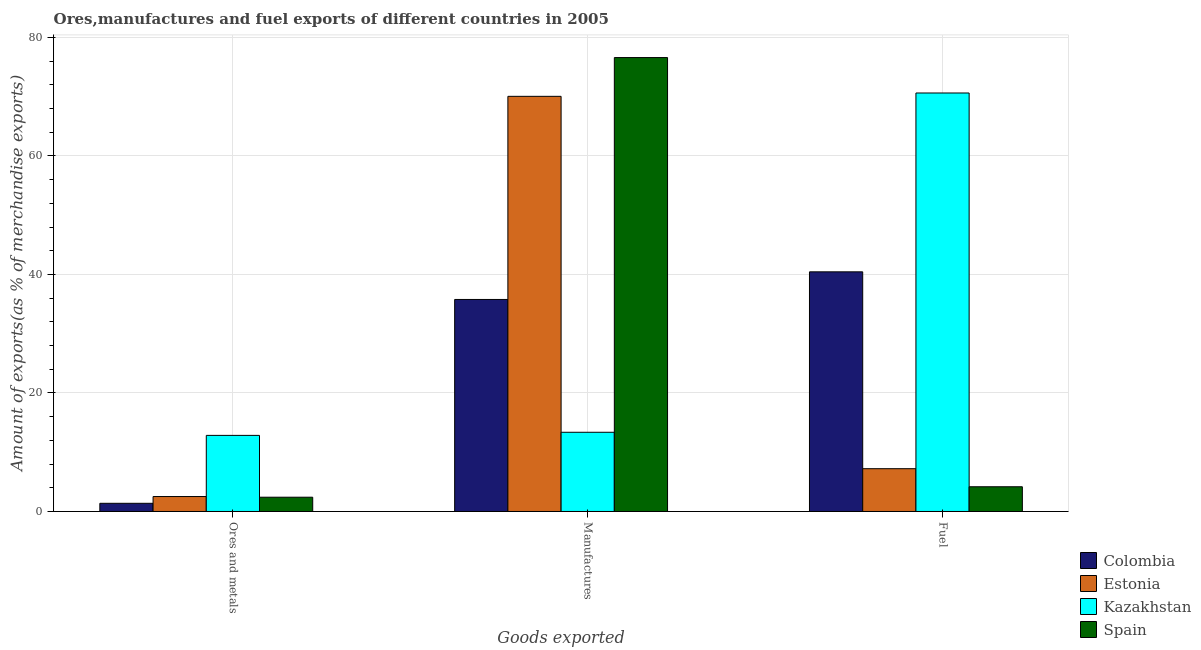How many groups of bars are there?
Ensure brevity in your answer.  3. Are the number of bars per tick equal to the number of legend labels?
Your answer should be very brief. Yes. Are the number of bars on each tick of the X-axis equal?
Provide a succinct answer. Yes. How many bars are there on the 2nd tick from the left?
Offer a very short reply. 4. How many bars are there on the 3rd tick from the right?
Give a very brief answer. 4. What is the label of the 1st group of bars from the left?
Give a very brief answer. Ores and metals. What is the percentage of manufactures exports in Spain?
Provide a short and direct response. 76.6. Across all countries, what is the maximum percentage of manufactures exports?
Your answer should be very brief. 76.6. Across all countries, what is the minimum percentage of fuel exports?
Provide a short and direct response. 4.17. In which country was the percentage of fuel exports maximum?
Offer a terse response. Kazakhstan. In which country was the percentage of manufactures exports minimum?
Make the answer very short. Kazakhstan. What is the total percentage of manufactures exports in the graph?
Give a very brief answer. 195.8. What is the difference between the percentage of manufactures exports in Colombia and that in Spain?
Make the answer very short. -40.82. What is the difference between the percentage of manufactures exports in Spain and the percentage of fuel exports in Estonia?
Offer a very short reply. 69.38. What is the average percentage of manufactures exports per country?
Ensure brevity in your answer.  48.95. What is the difference between the percentage of manufactures exports and percentage of fuel exports in Colombia?
Offer a terse response. -4.66. In how many countries, is the percentage of manufactures exports greater than 72 %?
Provide a succinct answer. 1. What is the ratio of the percentage of ores and metals exports in Estonia to that in Colombia?
Provide a short and direct response. 1.83. Is the percentage of manufactures exports in Spain less than that in Colombia?
Make the answer very short. No. Is the difference between the percentage of fuel exports in Spain and Colombia greater than the difference between the percentage of ores and metals exports in Spain and Colombia?
Offer a very short reply. No. What is the difference between the highest and the second highest percentage of manufactures exports?
Your answer should be very brief. 6.54. What is the difference between the highest and the lowest percentage of manufactures exports?
Provide a succinct answer. 63.23. In how many countries, is the percentage of fuel exports greater than the average percentage of fuel exports taken over all countries?
Ensure brevity in your answer.  2. Is the sum of the percentage of ores and metals exports in Kazakhstan and Estonia greater than the maximum percentage of fuel exports across all countries?
Keep it short and to the point. No. What does the 4th bar from the right in Fuel represents?
Provide a short and direct response. Colombia. Is it the case that in every country, the sum of the percentage of ores and metals exports and percentage of manufactures exports is greater than the percentage of fuel exports?
Give a very brief answer. No. How many bars are there?
Your response must be concise. 12. Where does the legend appear in the graph?
Your answer should be compact. Bottom right. What is the title of the graph?
Your answer should be compact. Ores,manufactures and fuel exports of different countries in 2005. What is the label or title of the X-axis?
Give a very brief answer. Goods exported. What is the label or title of the Y-axis?
Make the answer very short. Amount of exports(as % of merchandise exports). What is the Amount of exports(as % of merchandise exports) of Colombia in Ores and metals?
Make the answer very short. 1.38. What is the Amount of exports(as % of merchandise exports) of Estonia in Ores and metals?
Provide a succinct answer. 2.52. What is the Amount of exports(as % of merchandise exports) of Kazakhstan in Ores and metals?
Provide a succinct answer. 12.84. What is the Amount of exports(as % of merchandise exports) in Spain in Ores and metals?
Your answer should be very brief. 2.41. What is the Amount of exports(as % of merchandise exports) in Colombia in Manufactures?
Provide a short and direct response. 35.78. What is the Amount of exports(as % of merchandise exports) of Estonia in Manufactures?
Your answer should be very brief. 70.05. What is the Amount of exports(as % of merchandise exports) of Kazakhstan in Manufactures?
Provide a short and direct response. 13.37. What is the Amount of exports(as % of merchandise exports) in Spain in Manufactures?
Offer a very short reply. 76.6. What is the Amount of exports(as % of merchandise exports) in Colombia in Fuel?
Give a very brief answer. 40.44. What is the Amount of exports(as % of merchandise exports) of Estonia in Fuel?
Give a very brief answer. 7.22. What is the Amount of exports(as % of merchandise exports) of Kazakhstan in Fuel?
Your response must be concise. 70.62. What is the Amount of exports(as % of merchandise exports) in Spain in Fuel?
Make the answer very short. 4.17. Across all Goods exported, what is the maximum Amount of exports(as % of merchandise exports) of Colombia?
Provide a succinct answer. 40.44. Across all Goods exported, what is the maximum Amount of exports(as % of merchandise exports) of Estonia?
Offer a terse response. 70.05. Across all Goods exported, what is the maximum Amount of exports(as % of merchandise exports) in Kazakhstan?
Offer a very short reply. 70.62. Across all Goods exported, what is the maximum Amount of exports(as % of merchandise exports) in Spain?
Your answer should be very brief. 76.6. Across all Goods exported, what is the minimum Amount of exports(as % of merchandise exports) in Colombia?
Keep it short and to the point. 1.38. Across all Goods exported, what is the minimum Amount of exports(as % of merchandise exports) of Estonia?
Offer a very short reply. 2.52. Across all Goods exported, what is the minimum Amount of exports(as % of merchandise exports) of Kazakhstan?
Give a very brief answer. 12.84. Across all Goods exported, what is the minimum Amount of exports(as % of merchandise exports) in Spain?
Your response must be concise. 2.41. What is the total Amount of exports(as % of merchandise exports) of Colombia in the graph?
Ensure brevity in your answer.  77.6. What is the total Amount of exports(as % of merchandise exports) in Estonia in the graph?
Your answer should be compact. 79.79. What is the total Amount of exports(as % of merchandise exports) of Kazakhstan in the graph?
Your answer should be very brief. 96.83. What is the total Amount of exports(as % of merchandise exports) of Spain in the graph?
Your response must be concise. 83.18. What is the difference between the Amount of exports(as % of merchandise exports) of Colombia in Ores and metals and that in Manufactures?
Give a very brief answer. -34.4. What is the difference between the Amount of exports(as % of merchandise exports) in Estonia in Ores and metals and that in Manufactures?
Provide a succinct answer. -67.53. What is the difference between the Amount of exports(as % of merchandise exports) of Kazakhstan in Ores and metals and that in Manufactures?
Provide a short and direct response. -0.53. What is the difference between the Amount of exports(as % of merchandise exports) of Spain in Ores and metals and that in Manufactures?
Ensure brevity in your answer.  -74.19. What is the difference between the Amount of exports(as % of merchandise exports) of Colombia in Ores and metals and that in Fuel?
Your answer should be compact. -39.06. What is the difference between the Amount of exports(as % of merchandise exports) in Estonia in Ores and metals and that in Fuel?
Provide a short and direct response. -4.7. What is the difference between the Amount of exports(as % of merchandise exports) of Kazakhstan in Ores and metals and that in Fuel?
Your answer should be very brief. -57.78. What is the difference between the Amount of exports(as % of merchandise exports) in Spain in Ores and metals and that in Fuel?
Your response must be concise. -1.77. What is the difference between the Amount of exports(as % of merchandise exports) in Colombia in Manufactures and that in Fuel?
Keep it short and to the point. -4.66. What is the difference between the Amount of exports(as % of merchandise exports) of Estonia in Manufactures and that in Fuel?
Your answer should be very brief. 62.84. What is the difference between the Amount of exports(as % of merchandise exports) of Kazakhstan in Manufactures and that in Fuel?
Provide a short and direct response. -57.25. What is the difference between the Amount of exports(as % of merchandise exports) in Spain in Manufactures and that in Fuel?
Your answer should be very brief. 72.42. What is the difference between the Amount of exports(as % of merchandise exports) in Colombia in Ores and metals and the Amount of exports(as % of merchandise exports) in Estonia in Manufactures?
Keep it short and to the point. -68.67. What is the difference between the Amount of exports(as % of merchandise exports) in Colombia in Ores and metals and the Amount of exports(as % of merchandise exports) in Kazakhstan in Manufactures?
Your answer should be very brief. -11.99. What is the difference between the Amount of exports(as % of merchandise exports) in Colombia in Ores and metals and the Amount of exports(as % of merchandise exports) in Spain in Manufactures?
Give a very brief answer. -75.21. What is the difference between the Amount of exports(as % of merchandise exports) in Estonia in Ores and metals and the Amount of exports(as % of merchandise exports) in Kazakhstan in Manufactures?
Offer a terse response. -10.85. What is the difference between the Amount of exports(as % of merchandise exports) in Estonia in Ores and metals and the Amount of exports(as % of merchandise exports) in Spain in Manufactures?
Make the answer very short. -74.07. What is the difference between the Amount of exports(as % of merchandise exports) of Kazakhstan in Ores and metals and the Amount of exports(as % of merchandise exports) of Spain in Manufactures?
Offer a very short reply. -63.75. What is the difference between the Amount of exports(as % of merchandise exports) of Colombia in Ores and metals and the Amount of exports(as % of merchandise exports) of Estonia in Fuel?
Your response must be concise. -5.84. What is the difference between the Amount of exports(as % of merchandise exports) in Colombia in Ores and metals and the Amount of exports(as % of merchandise exports) in Kazakhstan in Fuel?
Make the answer very short. -69.24. What is the difference between the Amount of exports(as % of merchandise exports) in Colombia in Ores and metals and the Amount of exports(as % of merchandise exports) in Spain in Fuel?
Your answer should be very brief. -2.79. What is the difference between the Amount of exports(as % of merchandise exports) in Estonia in Ores and metals and the Amount of exports(as % of merchandise exports) in Kazakhstan in Fuel?
Make the answer very short. -68.1. What is the difference between the Amount of exports(as % of merchandise exports) in Estonia in Ores and metals and the Amount of exports(as % of merchandise exports) in Spain in Fuel?
Give a very brief answer. -1.65. What is the difference between the Amount of exports(as % of merchandise exports) of Kazakhstan in Ores and metals and the Amount of exports(as % of merchandise exports) of Spain in Fuel?
Keep it short and to the point. 8.67. What is the difference between the Amount of exports(as % of merchandise exports) in Colombia in Manufactures and the Amount of exports(as % of merchandise exports) in Estonia in Fuel?
Offer a terse response. 28.56. What is the difference between the Amount of exports(as % of merchandise exports) of Colombia in Manufactures and the Amount of exports(as % of merchandise exports) of Kazakhstan in Fuel?
Ensure brevity in your answer.  -34.84. What is the difference between the Amount of exports(as % of merchandise exports) of Colombia in Manufactures and the Amount of exports(as % of merchandise exports) of Spain in Fuel?
Your answer should be very brief. 31.61. What is the difference between the Amount of exports(as % of merchandise exports) in Estonia in Manufactures and the Amount of exports(as % of merchandise exports) in Kazakhstan in Fuel?
Your response must be concise. -0.56. What is the difference between the Amount of exports(as % of merchandise exports) in Estonia in Manufactures and the Amount of exports(as % of merchandise exports) in Spain in Fuel?
Offer a terse response. 65.88. What is the difference between the Amount of exports(as % of merchandise exports) in Kazakhstan in Manufactures and the Amount of exports(as % of merchandise exports) in Spain in Fuel?
Keep it short and to the point. 9.19. What is the average Amount of exports(as % of merchandise exports) in Colombia per Goods exported?
Offer a terse response. 25.87. What is the average Amount of exports(as % of merchandise exports) of Estonia per Goods exported?
Offer a very short reply. 26.6. What is the average Amount of exports(as % of merchandise exports) of Kazakhstan per Goods exported?
Ensure brevity in your answer.  32.28. What is the average Amount of exports(as % of merchandise exports) of Spain per Goods exported?
Your answer should be very brief. 27.73. What is the difference between the Amount of exports(as % of merchandise exports) of Colombia and Amount of exports(as % of merchandise exports) of Estonia in Ores and metals?
Provide a succinct answer. -1.14. What is the difference between the Amount of exports(as % of merchandise exports) in Colombia and Amount of exports(as % of merchandise exports) in Kazakhstan in Ores and metals?
Keep it short and to the point. -11.46. What is the difference between the Amount of exports(as % of merchandise exports) in Colombia and Amount of exports(as % of merchandise exports) in Spain in Ores and metals?
Your response must be concise. -1.03. What is the difference between the Amount of exports(as % of merchandise exports) of Estonia and Amount of exports(as % of merchandise exports) of Kazakhstan in Ores and metals?
Your answer should be compact. -10.32. What is the difference between the Amount of exports(as % of merchandise exports) of Estonia and Amount of exports(as % of merchandise exports) of Spain in Ores and metals?
Your answer should be compact. 0.11. What is the difference between the Amount of exports(as % of merchandise exports) of Kazakhstan and Amount of exports(as % of merchandise exports) of Spain in Ores and metals?
Your answer should be compact. 10.43. What is the difference between the Amount of exports(as % of merchandise exports) of Colombia and Amount of exports(as % of merchandise exports) of Estonia in Manufactures?
Provide a succinct answer. -34.28. What is the difference between the Amount of exports(as % of merchandise exports) in Colombia and Amount of exports(as % of merchandise exports) in Kazakhstan in Manufactures?
Give a very brief answer. 22.41. What is the difference between the Amount of exports(as % of merchandise exports) of Colombia and Amount of exports(as % of merchandise exports) of Spain in Manufactures?
Your response must be concise. -40.82. What is the difference between the Amount of exports(as % of merchandise exports) in Estonia and Amount of exports(as % of merchandise exports) in Kazakhstan in Manufactures?
Offer a very short reply. 56.69. What is the difference between the Amount of exports(as % of merchandise exports) in Estonia and Amount of exports(as % of merchandise exports) in Spain in Manufactures?
Your answer should be very brief. -6.54. What is the difference between the Amount of exports(as % of merchandise exports) of Kazakhstan and Amount of exports(as % of merchandise exports) of Spain in Manufactures?
Your response must be concise. -63.23. What is the difference between the Amount of exports(as % of merchandise exports) in Colombia and Amount of exports(as % of merchandise exports) in Estonia in Fuel?
Your answer should be very brief. 33.22. What is the difference between the Amount of exports(as % of merchandise exports) in Colombia and Amount of exports(as % of merchandise exports) in Kazakhstan in Fuel?
Keep it short and to the point. -30.18. What is the difference between the Amount of exports(as % of merchandise exports) in Colombia and Amount of exports(as % of merchandise exports) in Spain in Fuel?
Keep it short and to the point. 36.27. What is the difference between the Amount of exports(as % of merchandise exports) in Estonia and Amount of exports(as % of merchandise exports) in Kazakhstan in Fuel?
Offer a terse response. -63.4. What is the difference between the Amount of exports(as % of merchandise exports) in Estonia and Amount of exports(as % of merchandise exports) in Spain in Fuel?
Offer a terse response. 3.05. What is the difference between the Amount of exports(as % of merchandise exports) in Kazakhstan and Amount of exports(as % of merchandise exports) in Spain in Fuel?
Offer a terse response. 66.44. What is the ratio of the Amount of exports(as % of merchandise exports) of Colombia in Ores and metals to that in Manufactures?
Keep it short and to the point. 0.04. What is the ratio of the Amount of exports(as % of merchandise exports) of Estonia in Ores and metals to that in Manufactures?
Your answer should be compact. 0.04. What is the ratio of the Amount of exports(as % of merchandise exports) in Kazakhstan in Ores and metals to that in Manufactures?
Keep it short and to the point. 0.96. What is the ratio of the Amount of exports(as % of merchandise exports) in Spain in Ores and metals to that in Manufactures?
Offer a very short reply. 0.03. What is the ratio of the Amount of exports(as % of merchandise exports) of Colombia in Ores and metals to that in Fuel?
Give a very brief answer. 0.03. What is the ratio of the Amount of exports(as % of merchandise exports) of Estonia in Ores and metals to that in Fuel?
Offer a very short reply. 0.35. What is the ratio of the Amount of exports(as % of merchandise exports) of Kazakhstan in Ores and metals to that in Fuel?
Provide a succinct answer. 0.18. What is the ratio of the Amount of exports(as % of merchandise exports) of Spain in Ores and metals to that in Fuel?
Your response must be concise. 0.58. What is the ratio of the Amount of exports(as % of merchandise exports) of Colombia in Manufactures to that in Fuel?
Provide a succinct answer. 0.88. What is the ratio of the Amount of exports(as % of merchandise exports) of Estonia in Manufactures to that in Fuel?
Offer a very short reply. 9.7. What is the ratio of the Amount of exports(as % of merchandise exports) of Kazakhstan in Manufactures to that in Fuel?
Provide a succinct answer. 0.19. What is the ratio of the Amount of exports(as % of merchandise exports) in Spain in Manufactures to that in Fuel?
Your answer should be very brief. 18.35. What is the difference between the highest and the second highest Amount of exports(as % of merchandise exports) in Colombia?
Make the answer very short. 4.66. What is the difference between the highest and the second highest Amount of exports(as % of merchandise exports) in Estonia?
Give a very brief answer. 62.84. What is the difference between the highest and the second highest Amount of exports(as % of merchandise exports) of Kazakhstan?
Your answer should be very brief. 57.25. What is the difference between the highest and the second highest Amount of exports(as % of merchandise exports) in Spain?
Make the answer very short. 72.42. What is the difference between the highest and the lowest Amount of exports(as % of merchandise exports) in Colombia?
Offer a terse response. 39.06. What is the difference between the highest and the lowest Amount of exports(as % of merchandise exports) of Estonia?
Your response must be concise. 67.53. What is the difference between the highest and the lowest Amount of exports(as % of merchandise exports) of Kazakhstan?
Provide a short and direct response. 57.78. What is the difference between the highest and the lowest Amount of exports(as % of merchandise exports) of Spain?
Offer a terse response. 74.19. 